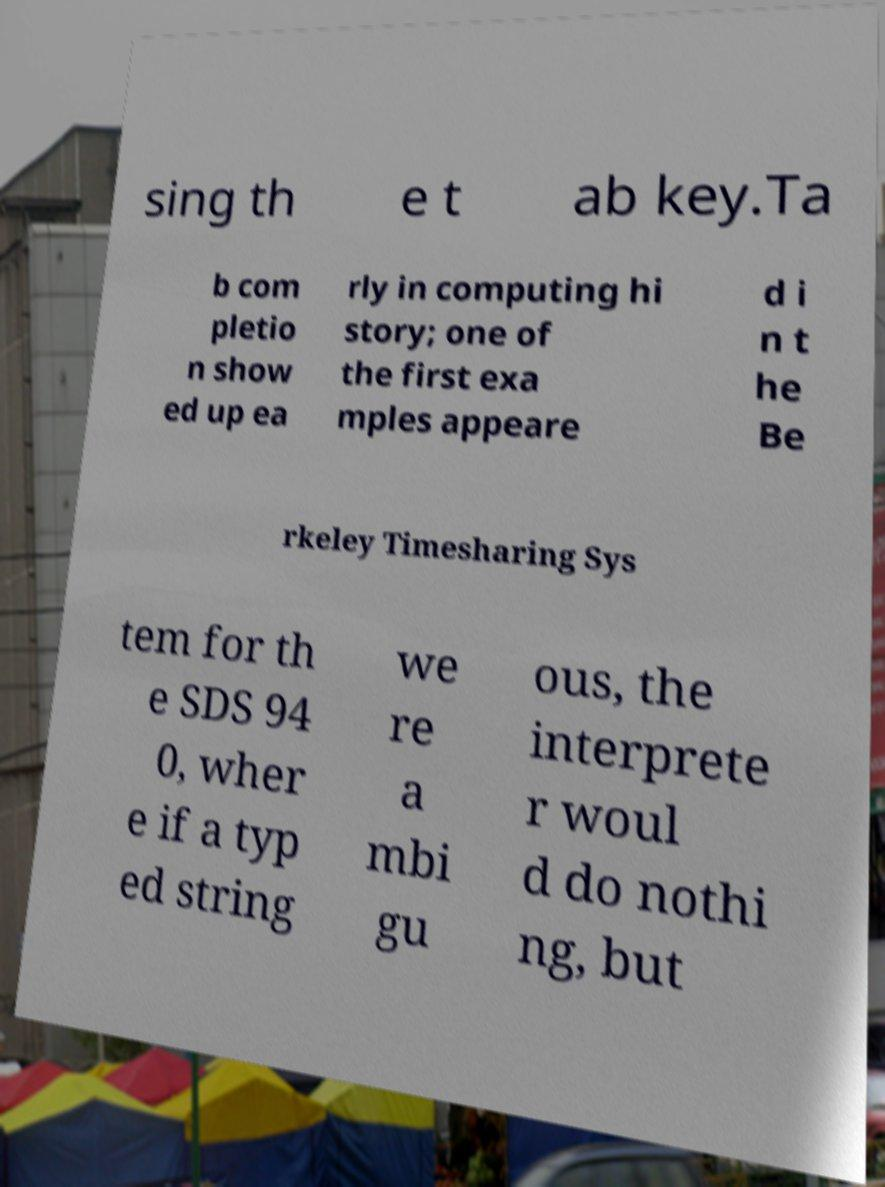Could you extract and type out the text from this image? sing th e t ab key.Ta b com pletio n show ed up ea rly in computing hi story; one of the first exa mples appeare d i n t he Be rkeley Timesharing Sys tem for th e SDS 94 0, wher e if a typ ed string we re a mbi gu ous, the interprete r woul d do nothi ng, but 